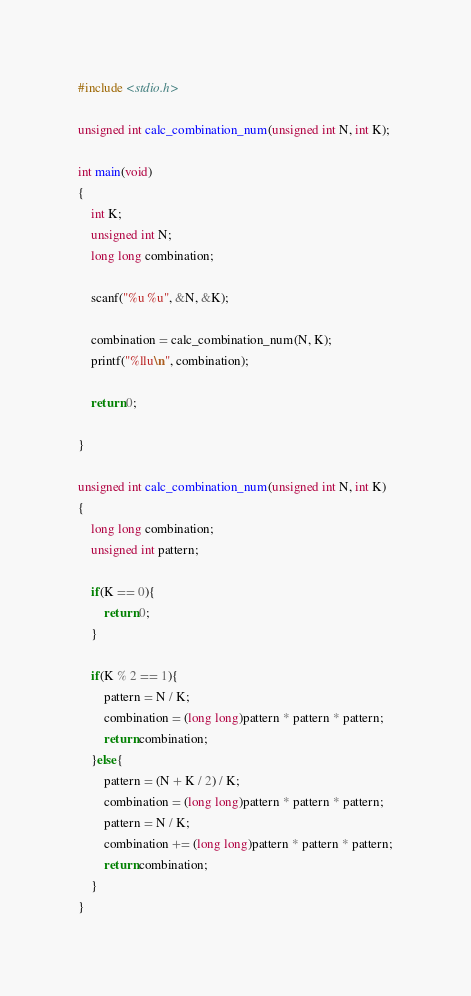<code> <loc_0><loc_0><loc_500><loc_500><_C_>#include <stdio.h>

unsigned int calc_combination_num(unsigned int N, int K);

int main(void)
{
    int K;
    unsigned int N;
    long long combination;

    scanf("%u %u", &N, &K);

    combination = calc_combination_num(N, K);
    printf("%llu\n", combination);
   
    return 0;

}

unsigned int calc_combination_num(unsigned int N, int K)
{
    long long combination;
    unsigned int pattern;

    if(K == 0){
        return 0;
    }

    if(K % 2 == 1){
        pattern = N / K;
        combination = (long long)pattern * pattern * pattern;
        return combination;
    }else{
        pattern = (N + K / 2) / K;
        combination = (long long)pattern * pattern * pattern;
        pattern = N / K;
        combination += (long long)pattern * pattern * pattern;
        return combination;
    }
}</code> 